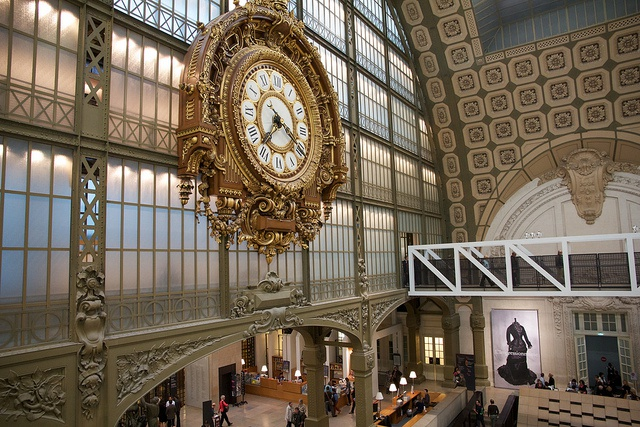Describe the objects in this image and their specific colors. I can see clock in tan and lightgray tones, people in tan, black, maroon, and gray tones, people in tan, black, gray, maroon, and brown tones, people in tan, black, gray, and maroon tones, and people in tan, black, maroon, and gray tones in this image. 